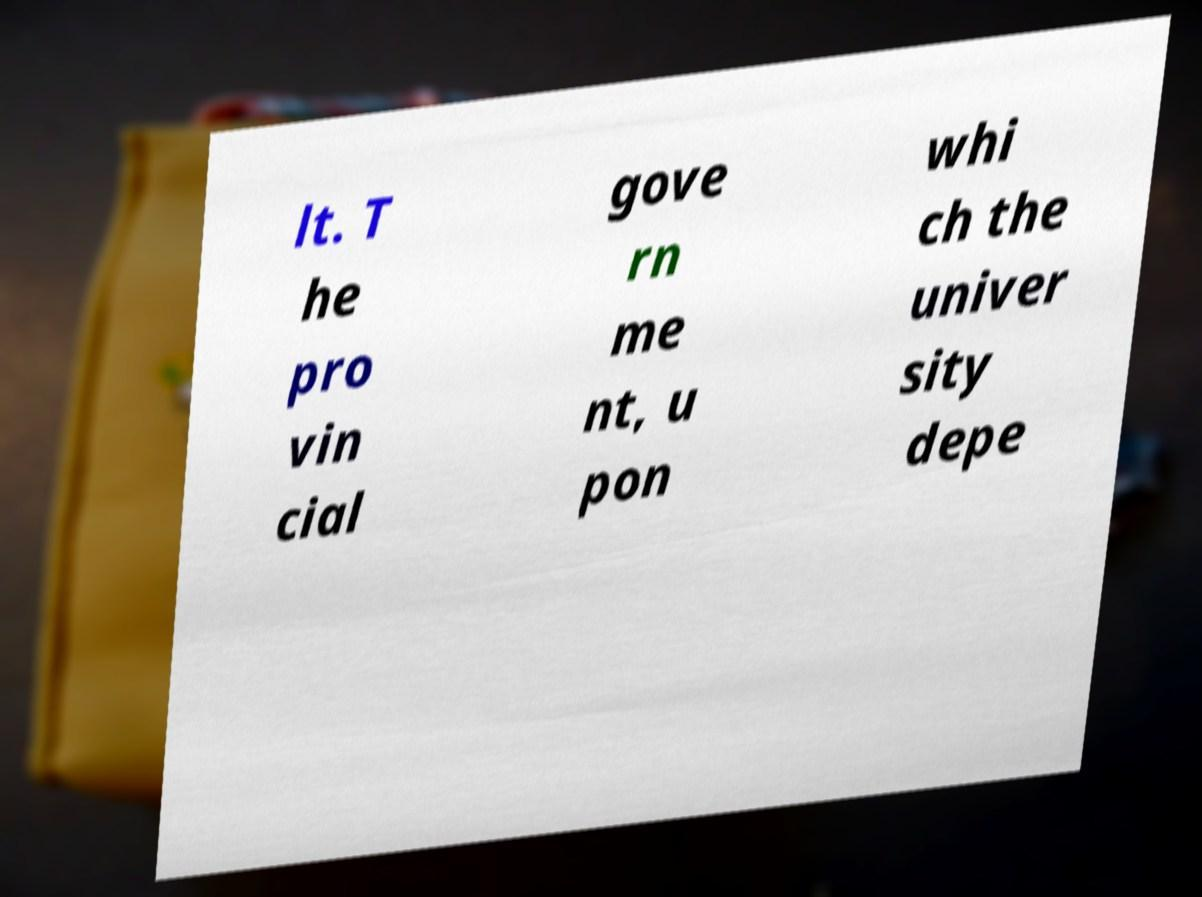Can you accurately transcribe the text from the provided image for me? lt. T he pro vin cial gove rn me nt, u pon whi ch the univer sity depe 